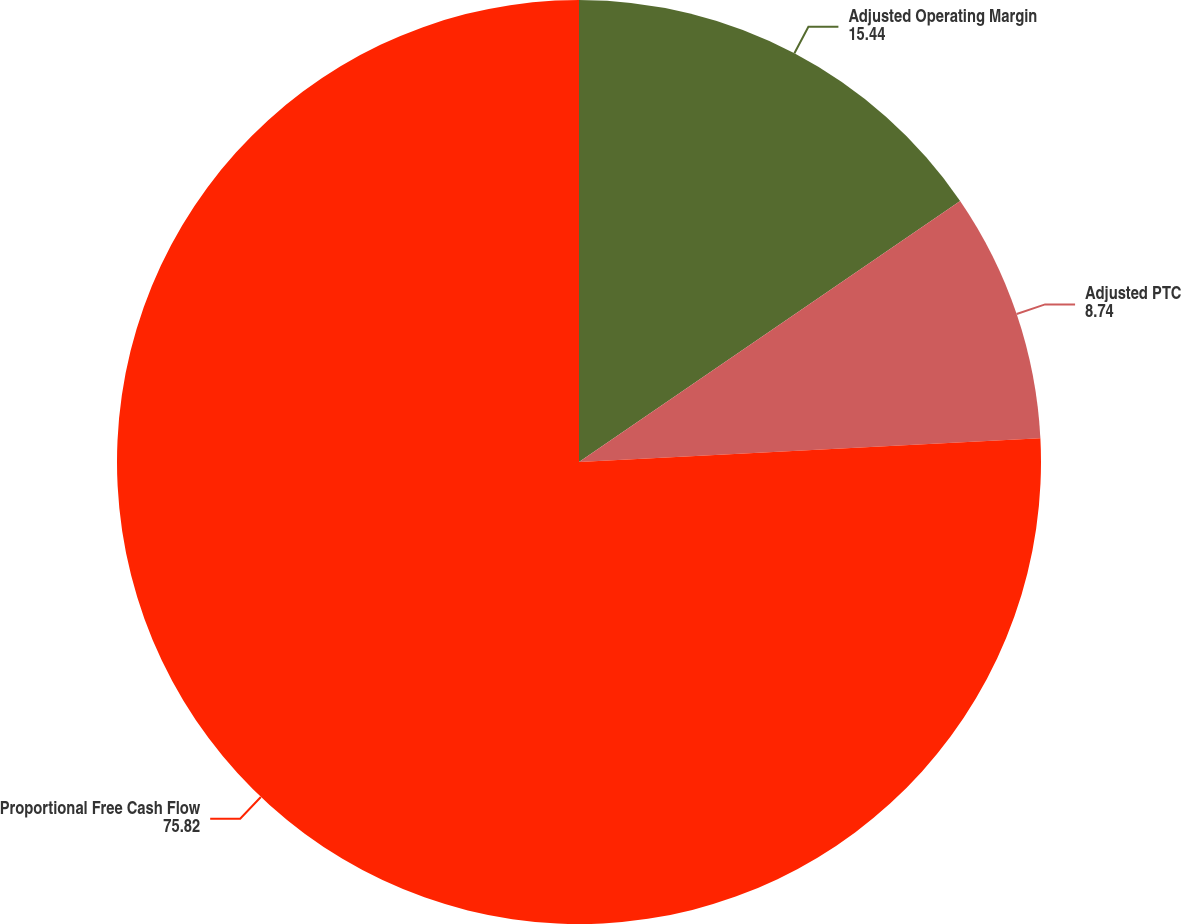<chart> <loc_0><loc_0><loc_500><loc_500><pie_chart><fcel>Adjusted Operating Margin<fcel>Adjusted PTC<fcel>Proportional Free Cash Flow<nl><fcel>15.44%<fcel>8.74%<fcel>75.82%<nl></chart> 